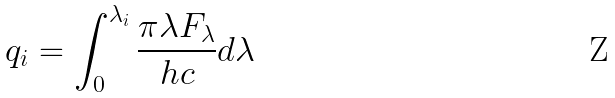Convert formula to latex. <formula><loc_0><loc_0><loc_500><loc_500>q _ { i } = \int ^ { \lambda _ { i } } _ { 0 } \frac { \pi \lambda F _ { \lambda } } { h c } d \lambda</formula> 